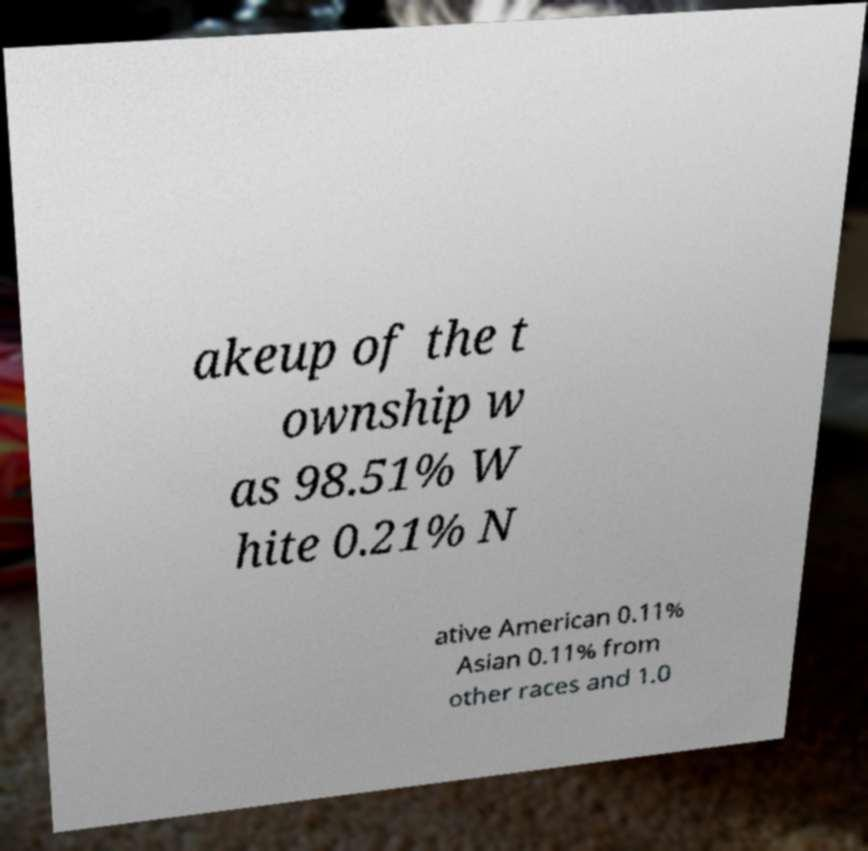Can you read and provide the text displayed in the image?This photo seems to have some interesting text. Can you extract and type it out for me? akeup of the t ownship w as 98.51% W hite 0.21% N ative American 0.11% Asian 0.11% from other races and 1.0 